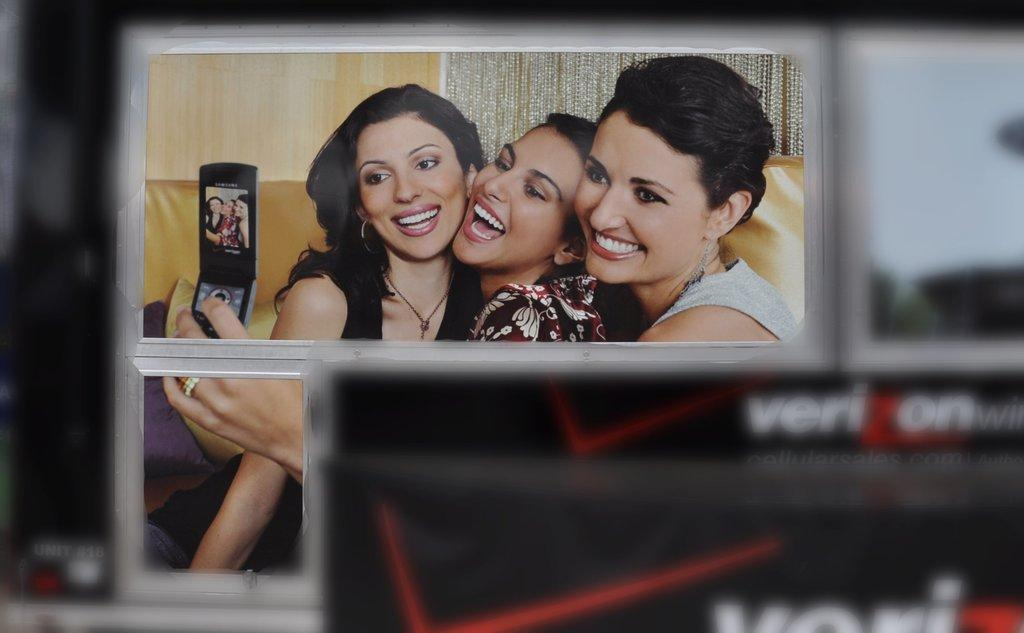How many people are in the image? There are three women in the image. What are the women doing in the image? The women are sitting and posing for a photo. Can you identify any objects the women are holding in the image? Yes, there is a woman holding a mobile phone in the image. What type of root can be seen growing from the woman's hand in the image? There is no root growing from any woman's hand in the image. 